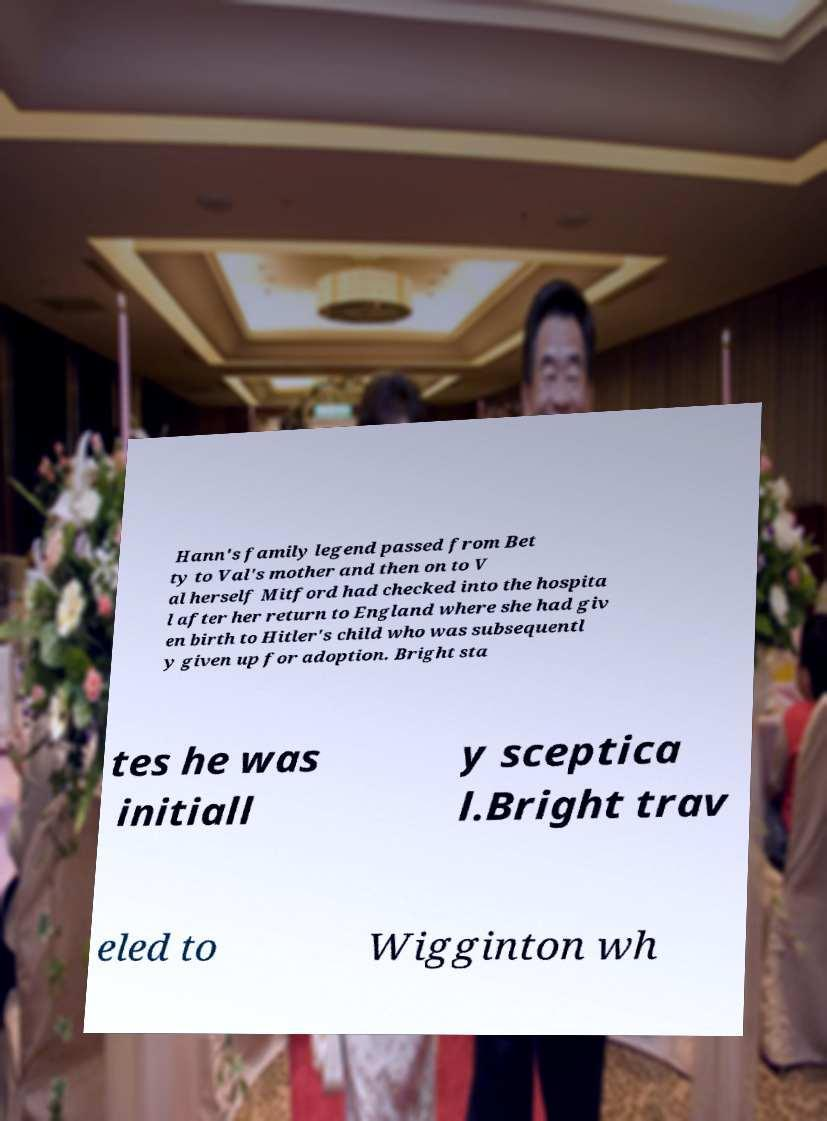Could you extract and type out the text from this image? Hann's family legend passed from Bet ty to Val's mother and then on to V al herself Mitford had checked into the hospita l after her return to England where she had giv en birth to Hitler's child who was subsequentl y given up for adoption. Bright sta tes he was initiall y sceptica l.Bright trav eled to Wigginton wh 